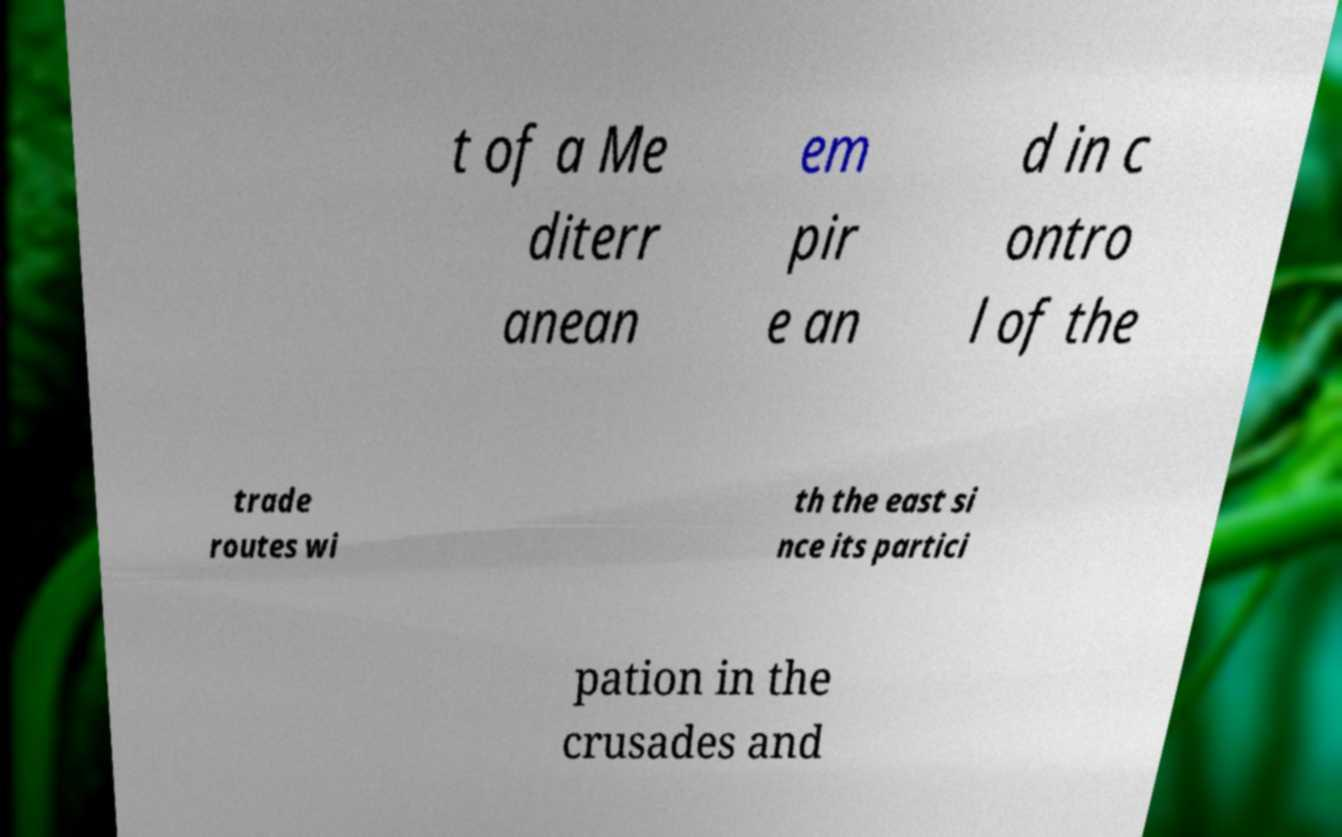I need the written content from this picture converted into text. Can you do that? t of a Me diterr anean em pir e an d in c ontro l of the trade routes wi th the east si nce its partici pation in the crusades and 